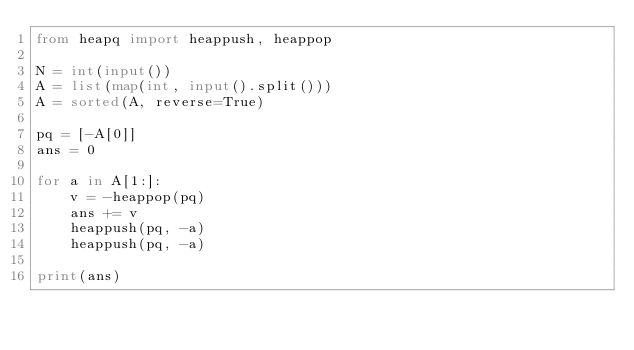Convert code to text. <code><loc_0><loc_0><loc_500><loc_500><_Python_>from heapq import heappush, heappop

N = int(input())
A = list(map(int, input().split()))
A = sorted(A, reverse=True)

pq = [-A[0]]
ans = 0

for a in A[1:]:
    v = -heappop(pq)
    ans += v
    heappush(pq, -a)
    heappush(pq, -a)

print(ans)

</code> 